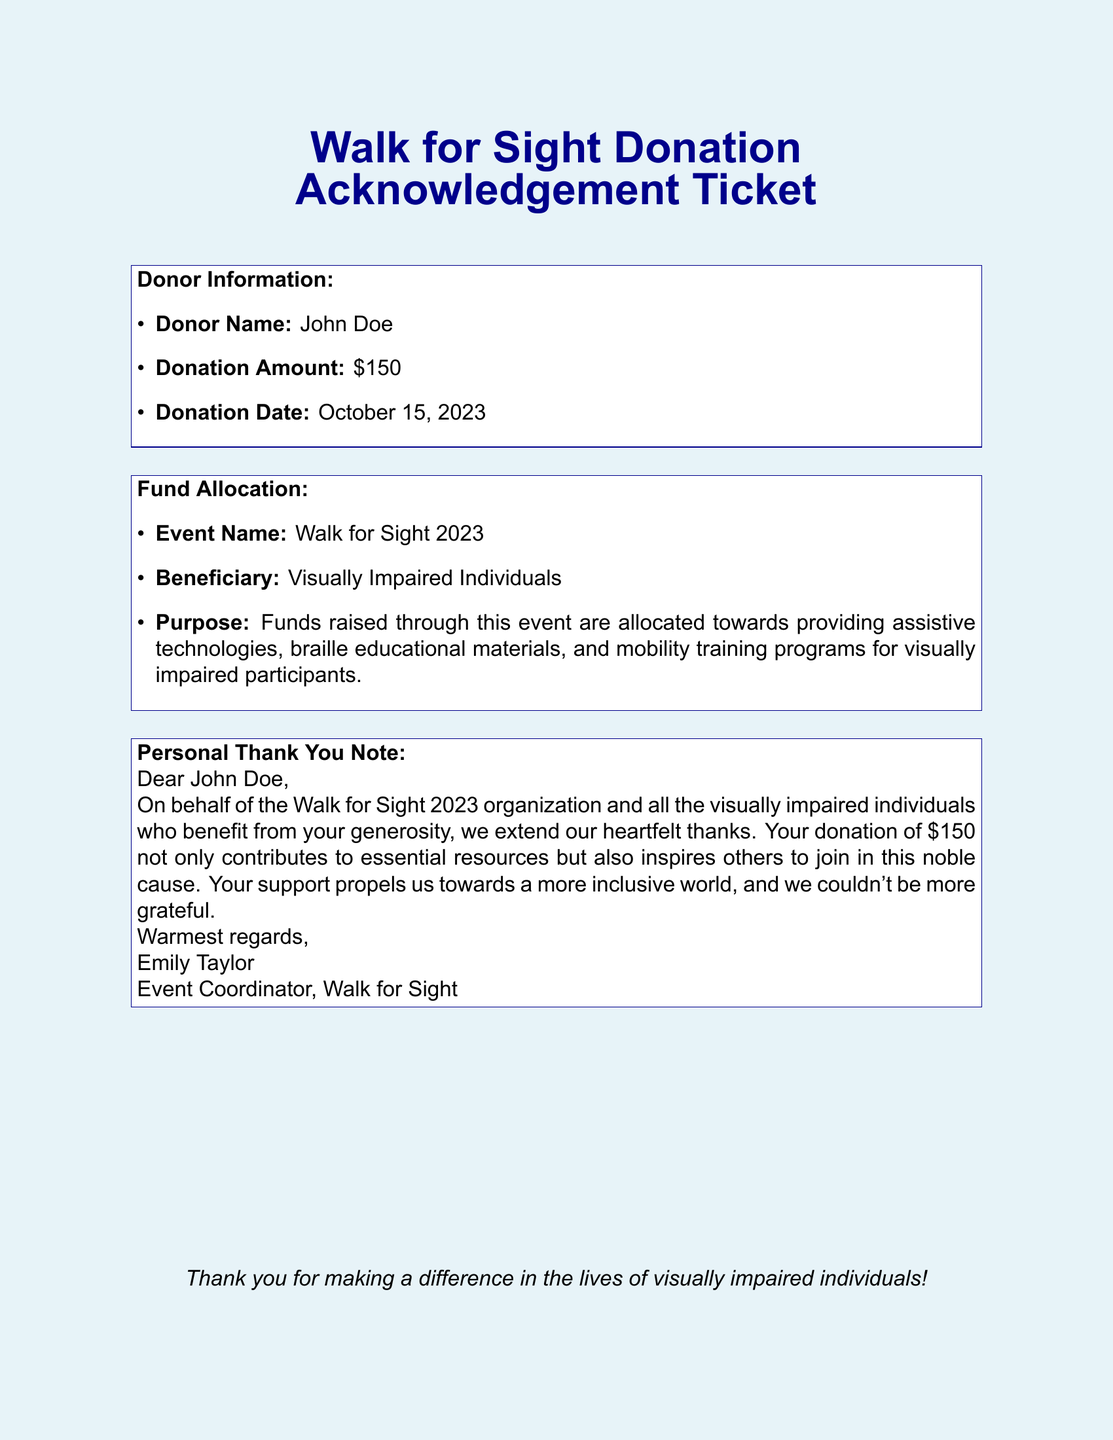What is the donor's name? The donor's name is explicitly mentioned in the donor information section of the document.
Answer: John Doe What was the donation amount? The donation amount is clearly stated in the donor information section.
Answer: $150 On what date was the donation made? The donation date is included in the donor information section of the document.
Answer: October 15, 2023 What event is the donation allocated to? The event name is listed under the fund allocation section.
Answer: Walk for Sight 2023 Who is the beneficiary of the funds raised? The beneficiary is specified in the fund allocation section of the document.
Answer: Visually Impaired Individuals What is one purpose of the funds raised? The purpose of the funds is described in detail within the fund allocation section.
Answer: Providing assistive technologies Who wrote the thank you note? The personal thank-you note includes the name of the person who wrote it.
Answer: Emily Taylor What is the role of the person who sent the thank-you note? The role of the person is mentioned at the end of the thank-you note.
Answer: Event Coordinator How does the organization describe the impact of the donation? The impact of the donation is articulated in the thank-you note, summarizing its significance.
Answer: Inspires others to join in this noble cause 